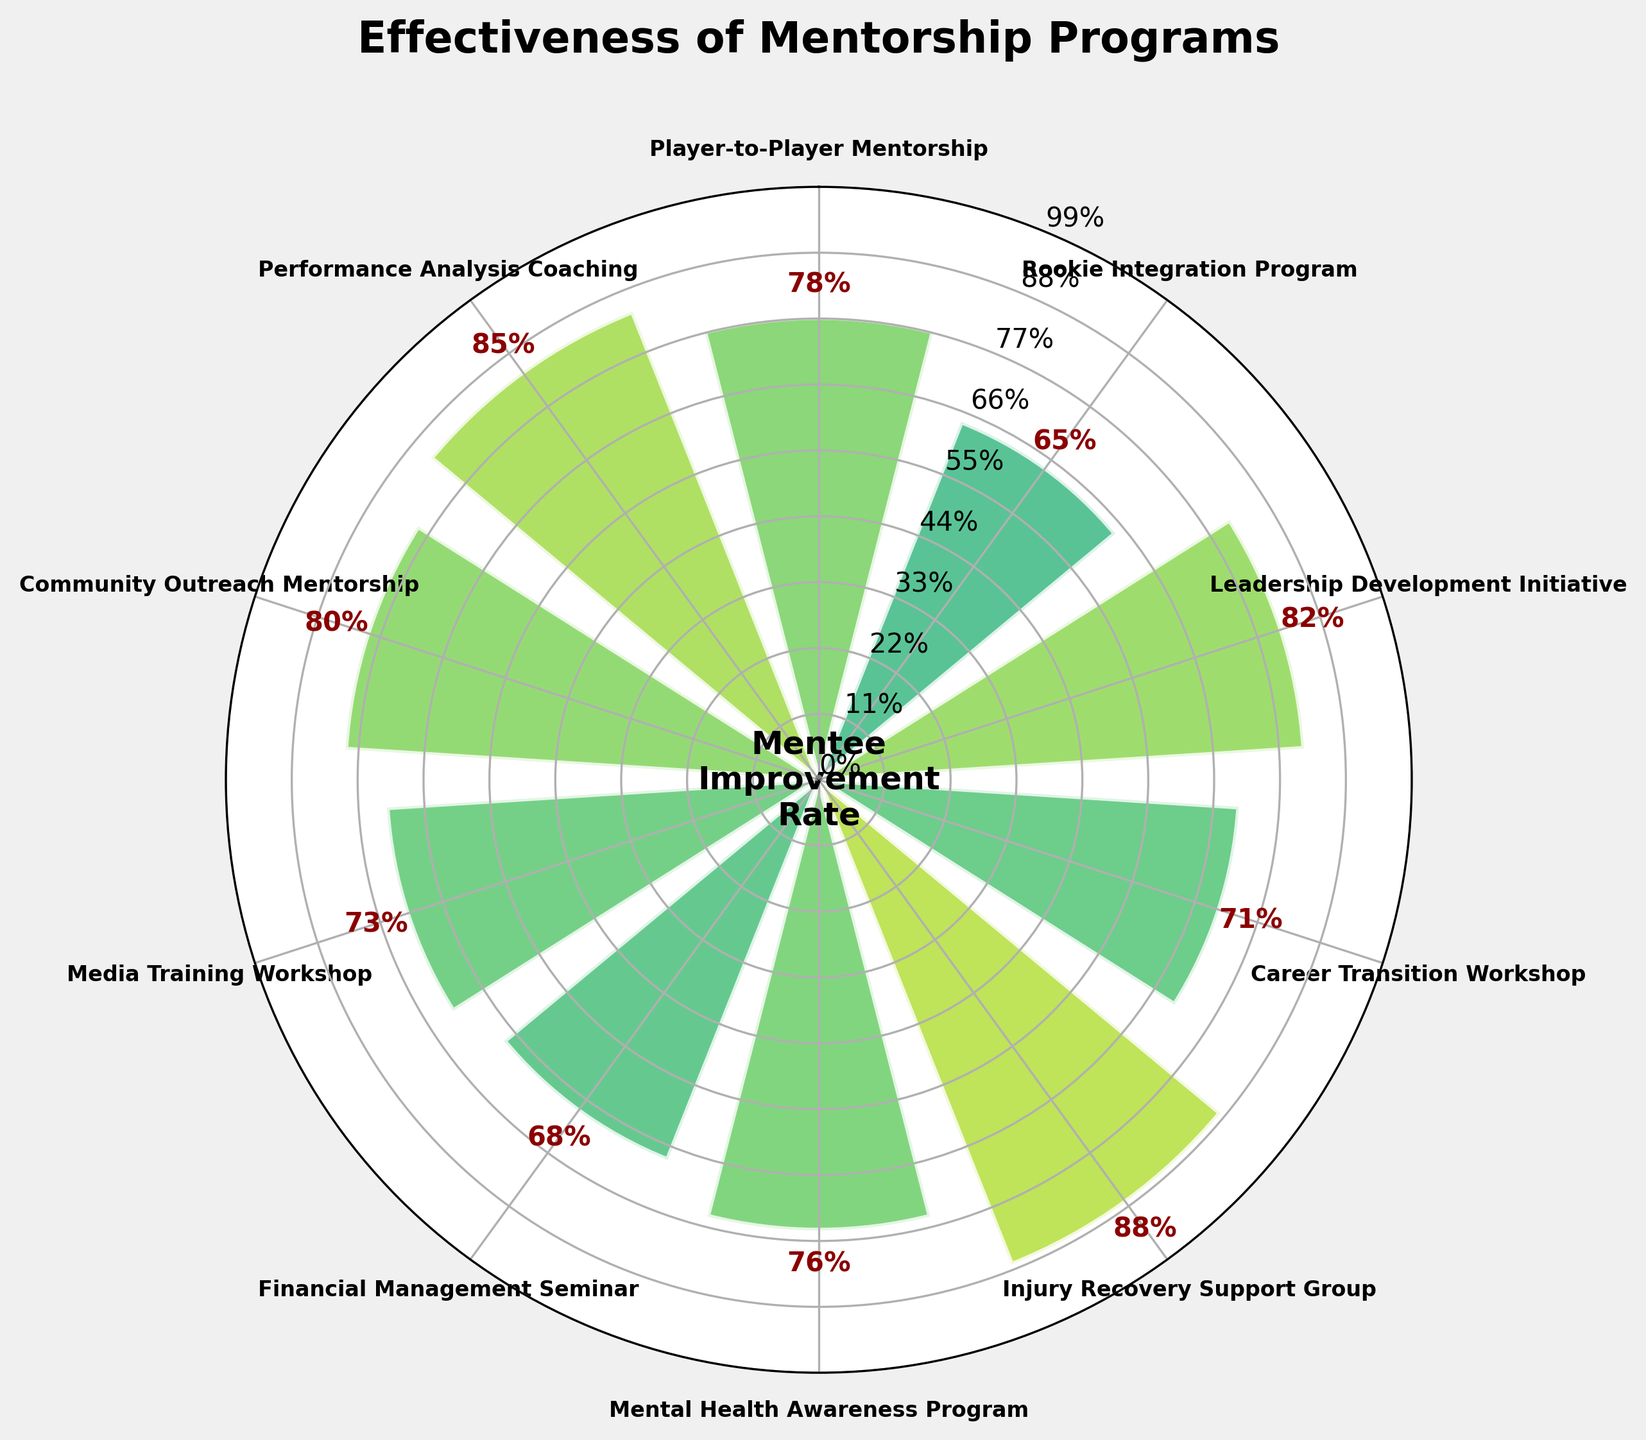What's the title of the figure? The title of the figure is the text located at the top center of the plot.
Answer: "Effectiveness of Mentorship Programs" How is the "Media Training Workshop" rate compared to the "Financial Management Seminar"? Locate the "Media Training Workshop" and "Financial Management Seminar" on the figure and compare their mentee improvement rates as percentages.
Answer: 73% vs 69% Which program has the highest mentee improvement rate, and what is it? Identify the program with the largest bar and check the rate next to it.
Answer: "Injury Recovery Support Group", 88% What's the average mentee improvement rate across all programs? Add all the improvement rates and divide by the number of programs: (78+65+82+71+88+76+69+73+80+85) / 10.
Answer: 76.7% What's the color of the bar representing the "Leadership Development Initiative"? The color of the bar can be described by visual observation of the plot's color scheme, which maps values to colors.
Answer: Varied greenish hue Which programs have more than an 80% improvement rate? Find all programs with bars greater than the 80% mark.
Answer: "Leadership Development Initiative", "Injury Recovery Support Group", "Community Outreach Mentorship", "Performance Analysis Coaching" How is the "Rookie Integration Program" doing compared to the "Career Transition Workshop"? Compare the heights of their respective bars and associated mentee improvement rates.
Answer: 65% vs 71% Rank the top three programs based on their improvement rates List the programs in descending order based on the heights of their bars.
Answer: "Injury Recovery Support Group" (88%), "Performance Analysis Coaching" (85%), "Leadership Development Initiative" (82%) What's the difference in the improvement rate between the "Player-to-Player Mentorship" and the "Mental Health Awareness Program"? Subtract the smaller rate from the larger rate:
Answer: 78% - 76% = 2% Identify the program with the lowest improvement rate and state the rate. Find the shortest bar and note its associated program and rate.
Answer: "Rookie Integration Program", 65% 